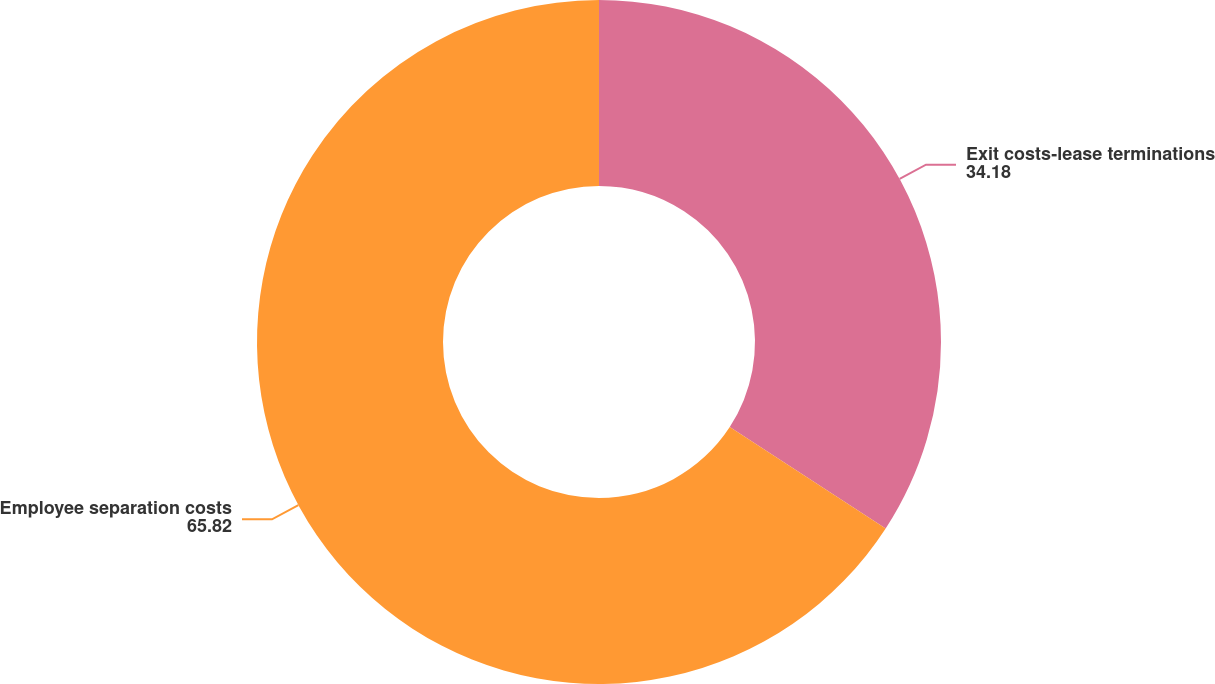Convert chart. <chart><loc_0><loc_0><loc_500><loc_500><pie_chart><fcel>Exit costs-lease terminations<fcel>Employee separation costs<nl><fcel>34.18%<fcel>65.82%<nl></chart> 